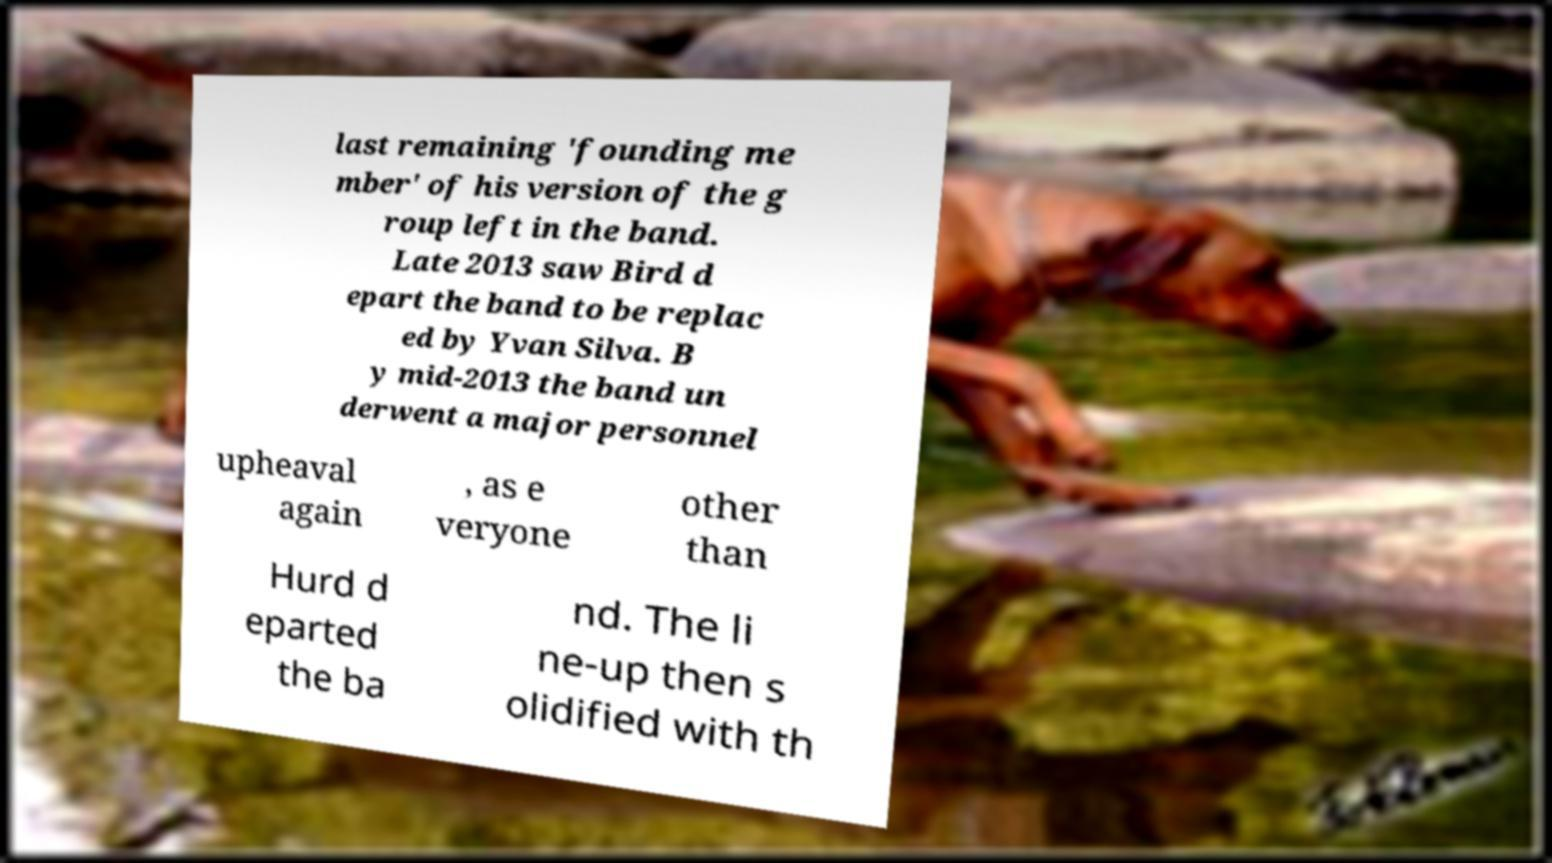Please read and relay the text visible in this image. What does it say? last remaining 'founding me mber' of his version of the g roup left in the band. Late 2013 saw Bird d epart the band to be replac ed by Yvan Silva. B y mid-2013 the band un derwent a major personnel upheaval again , as e veryone other than Hurd d eparted the ba nd. The li ne-up then s olidified with th 